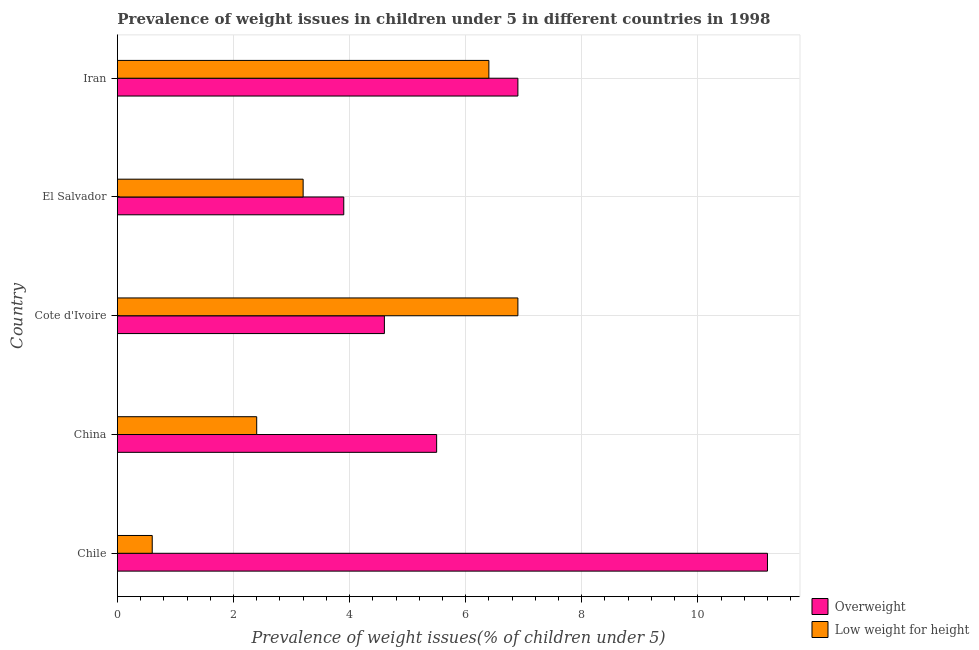How many groups of bars are there?
Give a very brief answer. 5. Are the number of bars per tick equal to the number of legend labels?
Give a very brief answer. Yes. How many bars are there on the 2nd tick from the top?
Your response must be concise. 2. How many bars are there on the 3rd tick from the bottom?
Your answer should be very brief. 2. In how many cases, is the number of bars for a given country not equal to the number of legend labels?
Provide a succinct answer. 0. What is the percentage of underweight children in Cote d'Ivoire?
Provide a short and direct response. 6.9. Across all countries, what is the maximum percentage of overweight children?
Keep it short and to the point. 11.2. Across all countries, what is the minimum percentage of underweight children?
Keep it short and to the point. 0.6. In which country was the percentage of underweight children maximum?
Provide a succinct answer. Cote d'Ivoire. What is the total percentage of overweight children in the graph?
Your answer should be very brief. 32.1. What is the difference between the percentage of underweight children in Cote d'Ivoire and the percentage of overweight children in Chile?
Make the answer very short. -4.3. What is the average percentage of overweight children per country?
Offer a terse response. 6.42. What is the ratio of the percentage of overweight children in El Salvador to that in Iran?
Offer a very short reply. 0.56. Is the percentage of overweight children in Chile less than that in El Salvador?
Make the answer very short. No. Is the difference between the percentage of overweight children in El Salvador and Iran greater than the difference between the percentage of underweight children in El Salvador and Iran?
Make the answer very short. Yes. What is the difference between the highest and the lowest percentage of underweight children?
Offer a terse response. 6.3. In how many countries, is the percentage of underweight children greater than the average percentage of underweight children taken over all countries?
Provide a succinct answer. 2. Is the sum of the percentage of underweight children in Cote d'Ivoire and El Salvador greater than the maximum percentage of overweight children across all countries?
Offer a terse response. No. What does the 2nd bar from the top in Chile represents?
Provide a succinct answer. Overweight. What does the 2nd bar from the bottom in Iran represents?
Ensure brevity in your answer.  Low weight for height. Are all the bars in the graph horizontal?
Keep it short and to the point. Yes. How many countries are there in the graph?
Your answer should be compact. 5. What is the difference between two consecutive major ticks on the X-axis?
Offer a terse response. 2. Are the values on the major ticks of X-axis written in scientific E-notation?
Keep it short and to the point. No. Does the graph contain grids?
Your answer should be very brief. Yes. Where does the legend appear in the graph?
Offer a terse response. Bottom right. How are the legend labels stacked?
Provide a short and direct response. Vertical. What is the title of the graph?
Offer a very short reply. Prevalence of weight issues in children under 5 in different countries in 1998. Does "Tetanus" appear as one of the legend labels in the graph?
Offer a terse response. No. What is the label or title of the X-axis?
Provide a succinct answer. Prevalence of weight issues(% of children under 5). What is the Prevalence of weight issues(% of children under 5) of Overweight in Chile?
Your answer should be compact. 11.2. What is the Prevalence of weight issues(% of children under 5) in Low weight for height in Chile?
Offer a very short reply. 0.6. What is the Prevalence of weight issues(% of children under 5) in Low weight for height in China?
Your answer should be compact. 2.4. What is the Prevalence of weight issues(% of children under 5) in Overweight in Cote d'Ivoire?
Keep it short and to the point. 4.6. What is the Prevalence of weight issues(% of children under 5) in Low weight for height in Cote d'Ivoire?
Your answer should be compact. 6.9. What is the Prevalence of weight issues(% of children under 5) in Overweight in El Salvador?
Provide a short and direct response. 3.9. What is the Prevalence of weight issues(% of children under 5) of Low weight for height in El Salvador?
Provide a short and direct response. 3.2. What is the Prevalence of weight issues(% of children under 5) of Overweight in Iran?
Make the answer very short. 6.9. What is the Prevalence of weight issues(% of children under 5) of Low weight for height in Iran?
Offer a very short reply. 6.4. Across all countries, what is the maximum Prevalence of weight issues(% of children under 5) of Overweight?
Your answer should be very brief. 11.2. Across all countries, what is the maximum Prevalence of weight issues(% of children under 5) of Low weight for height?
Your response must be concise. 6.9. Across all countries, what is the minimum Prevalence of weight issues(% of children under 5) in Overweight?
Offer a very short reply. 3.9. Across all countries, what is the minimum Prevalence of weight issues(% of children under 5) in Low weight for height?
Provide a succinct answer. 0.6. What is the total Prevalence of weight issues(% of children under 5) in Overweight in the graph?
Provide a succinct answer. 32.1. What is the difference between the Prevalence of weight issues(% of children under 5) of Overweight in Chile and that in Cote d'Ivoire?
Your answer should be very brief. 6.6. What is the difference between the Prevalence of weight issues(% of children under 5) of Overweight in Chile and that in El Salvador?
Make the answer very short. 7.3. What is the difference between the Prevalence of weight issues(% of children under 5) of Overweight in Chile and that in Iran?
Give a very brief answer. 4.3. What is the difference between the Prevalence of weight issues(% of children under 5) in Low weight for height in Chile and that in Iran?
Give a very brief answer. -5.8. What is the difference between the Prevalence of weight issues(% of children under 5) in Overweight in China and that in Cote d'Ivoire?
Your answer should be compact. 0.9. What is the difference between the Prevalence of weight issues(% of children under 5) in Low weight for height in China and that in Cote d'Ivoire?
Give a very brief answer. -4.5. What is the difference between the Prevalence of weight issues(% of children under 5) of Overweight in China and that in Iran?
Ensure brevity in your answer.  -1.4. What is the difference between the Prevalence of weight issues(% of children under 5) in Low weight for height in Cote d'Ivoire and that in Iran?
Make the answer very short. 0.5. What is the difference between the Prevalence of weight issues(% of children under 5) of Overweight in El Salvador and that in Iran?
Offer a terse response. -3. What is the difference between the Prevalence of weight issues(% of children under 5) of Low weight for height in El Salvador and that in Iran?
Your answer should be compact. -3.2. What is the difference between the Prevalence of weight issues(% of children under 5) in Overweight in Chile and the Prevalence of weight issues(% of children under 5) in Low weight for height in China?
Offer a terse response. 8.8. What is the difference between the Prevalence of weight issues(% of children under 5) in Overweight in Chile and the Prevalence of weight issues(% of children under 5) in Low weight for height in El Salvador?
Your response must be concise. 8. What is the difference between the Prevalence of weight issues(% of children under 5) of Overweight in Chile and the Prevalence of weight issues(% of children under 5) of Low weight for height in Iran?
Give a very brief answer. 4.8. What is the difference between the Prevalence of weight issues(% of children under 5) in Overweight in China and the Prevalence of weight issues(% of children under 5) in Low weight for height in Cote d'Ivoire?
Provide a succinct answer. -1.4. What is the difference between the Prevalence of weight issues(% of children under 5) of Overweight in Cote d'Ivoire and the Prevalence of weight issues(% of children under 5) of Low weight for height in Iran?
Ensure brevity in your answer.  -1.8. What is the difference between the Prevalence of weight issues(% of children under 5) in Overweight in El Salvador and the Prevalence of weight issues(% of children under 5) in Low weight for height in Iran?
Make the answer very short. -2.5. What is the average Prevalence of weight issues(% of children under 5) of Overweight per country?
Your answer should be very brief. 6.42. What is the average Prevalence of weight issues(% of children under 5) of Low weight for height per country?
Make the answer very short. 3.9. What is the difference between the Prevalence of weight issues(% of children under 5) in Overweight and Prevalence of weight issues(% of children under 5) in Low weight for height in Chile?
Provide a succinct answer. 10.6. What is the difference between the Prevalence of weight issues(% of children under 5) of Overweight and Prevalence of weight issues(% of children under 5) of Low weight for height in China?
Provide a succinct answer. 3.1. What is the ratio of the Prevalence of weight issues(% of children under 5) of Overweight in Chile to that in China?
Provide a short and direct response. 2.04. What is the ratio of the Prevalence of weight issues(% of children under 5) in Overweight in Chile to that in Cote d'Ivoire?
Your answer should be very brief. 2.43. What is the ratio of the Prevalence of weight issues(% of children under 5) of Low weight for height in Chile to that in Cote d'Ivoire?
Provide a succinct answer. 0.09. What is the ratio of the Prevalence of weight issues(% of children under 5) of Overweight in Chile to that in El Salvador?
Your response must be concise. 2.87. What is the ratio of the Prevalence of weight issues(% of children under 5) in Low weight for height in Chile to that in El Salvador?
Offer a terse response. 0.19. What is the ratio of the Prevalence of weight issues(% of children under 5) of Overweight in Chile to that in Iran?
Offer a very short reply. 1.62. What is the ratio of the Prevalence of weight issues(% of children under 5) in Low weight for height in Chile to that in Iran?
Ensure brevity in your answer.  0.09. What is the ratio of the Prevalence of weight issues(% of children under 5) in Overweight in China to that in Cote d'Ivoire?
Offer a terse response. 1.2. What is the ratio of the Prevalence of weight issues(% of children under 5) in Low weight for height in China to that in Cote d'Ivoire?
Offer a very short reply. 0.35. What is the ratio of the Prevalence of weight issues(% of children under 5) in Overweight in China to that in El Salvador?
Give a very brief answer. 1.41. What is the ratio of the Prevalence of weight issues(% of children under 5) in Low weight for height in China to that in El Salvador?
Make the answer very short. 0.75. What is the ratio of the Prevalence of weight issues(% of children under 5) of Overweight in China to that in Iran?
Make the answer very short. 0.8. What is the ratio of the Prevalence of weight issues(% of children under 5) of Overweight in Cote d'Ivoire to that in El Salvador?
Your answer should be very brief. 1.18. What is the ratio of the Prevalence of weight issues(% of children under 5) of Low weight for height in Cote d'Ivoire to that in El Salvador?
Provide a short and direct response. 2.16. What is the ratio of the Prevalence of weight issues(% of children under 5) of Low weight for height in Cote d'Ivoire to that in Iran?
Your response must be concise. 1.08. What is the ratio of the Prevalence of weight issues(% of children under 5) of Overweight in El Salvador to that in Iran?
Offer a very short reply. 0.57. What is the difference between the highest and the second highest Prevalence of weight issues(% of children under 5) in Low weight for height?
Give a very brief answer. 0.5. What is the difference between the highest and the lowest Prevalence of weight issues(% of children under 5) of Low weight for height?
Keep it short and to the point. 6.3. 